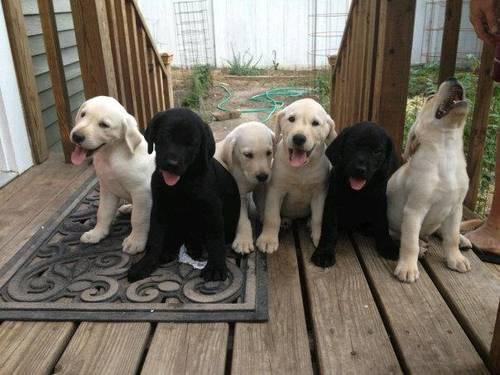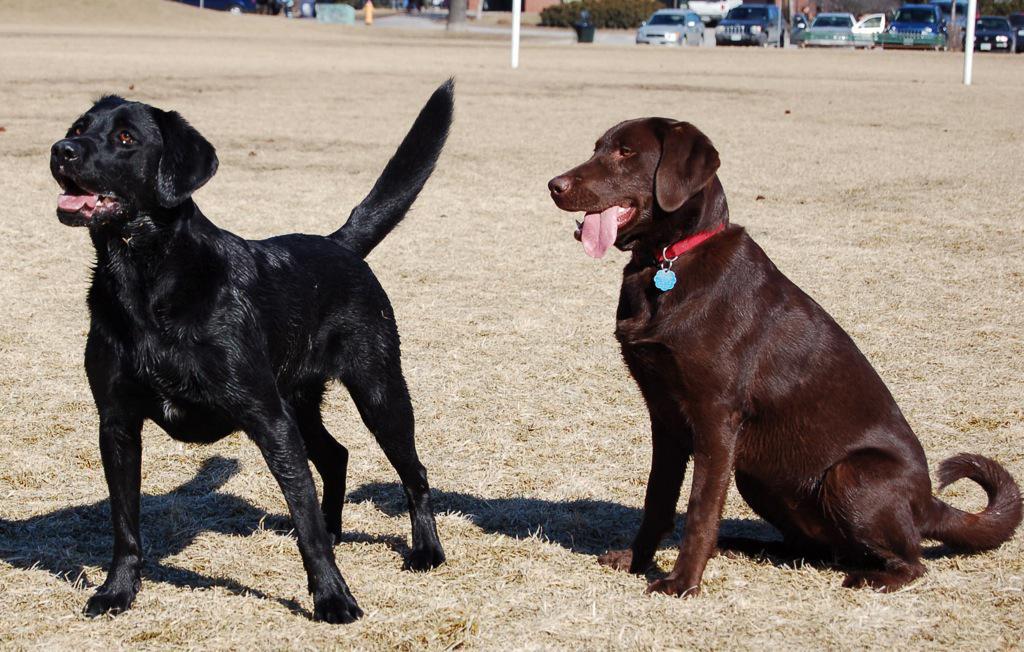The first image is the image on the left, the second image is the image on the right. For the images shown, is this caption "One image shows exactly two adult dogs, and the other image shows a row of at least three puppies sitting upright." true? Answer yes or no. Yes. The first image is the image on the left, the second image is the image on the right. Evaluate the accuracy of this statement regarding the images: "There are more dogs in the image on the left.". Is it true? Answer yes or no. Yes. 